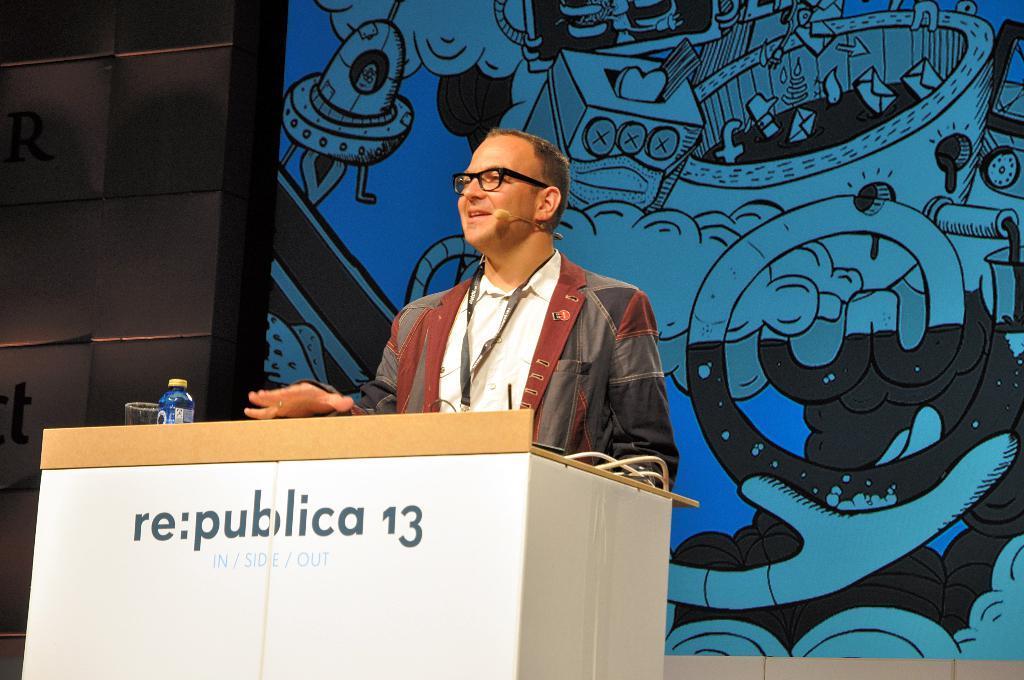Describe this image in one or two sentences. In this image I can see a person standing wearing gray and maroon color blazer, white shirt. In front I can see a podium. Background I can see the wall in blue, black and gray color. 